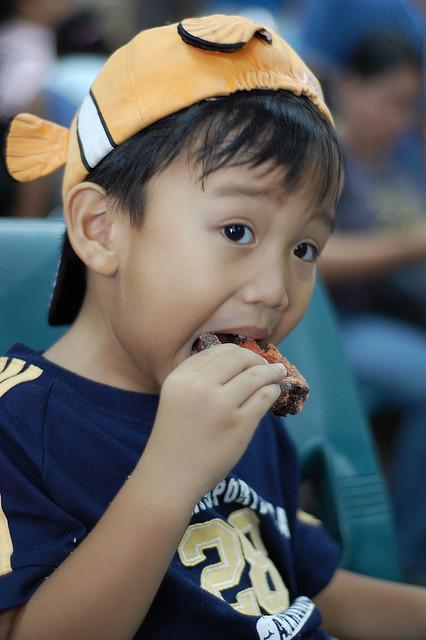Is the kid wearing a fish hat?
Quick response, please. Yes. Does the small boy's hair come down to his eyebrows?
Short answer required. Yes. Is the kid eating food?
Concise answer only. Yes. 